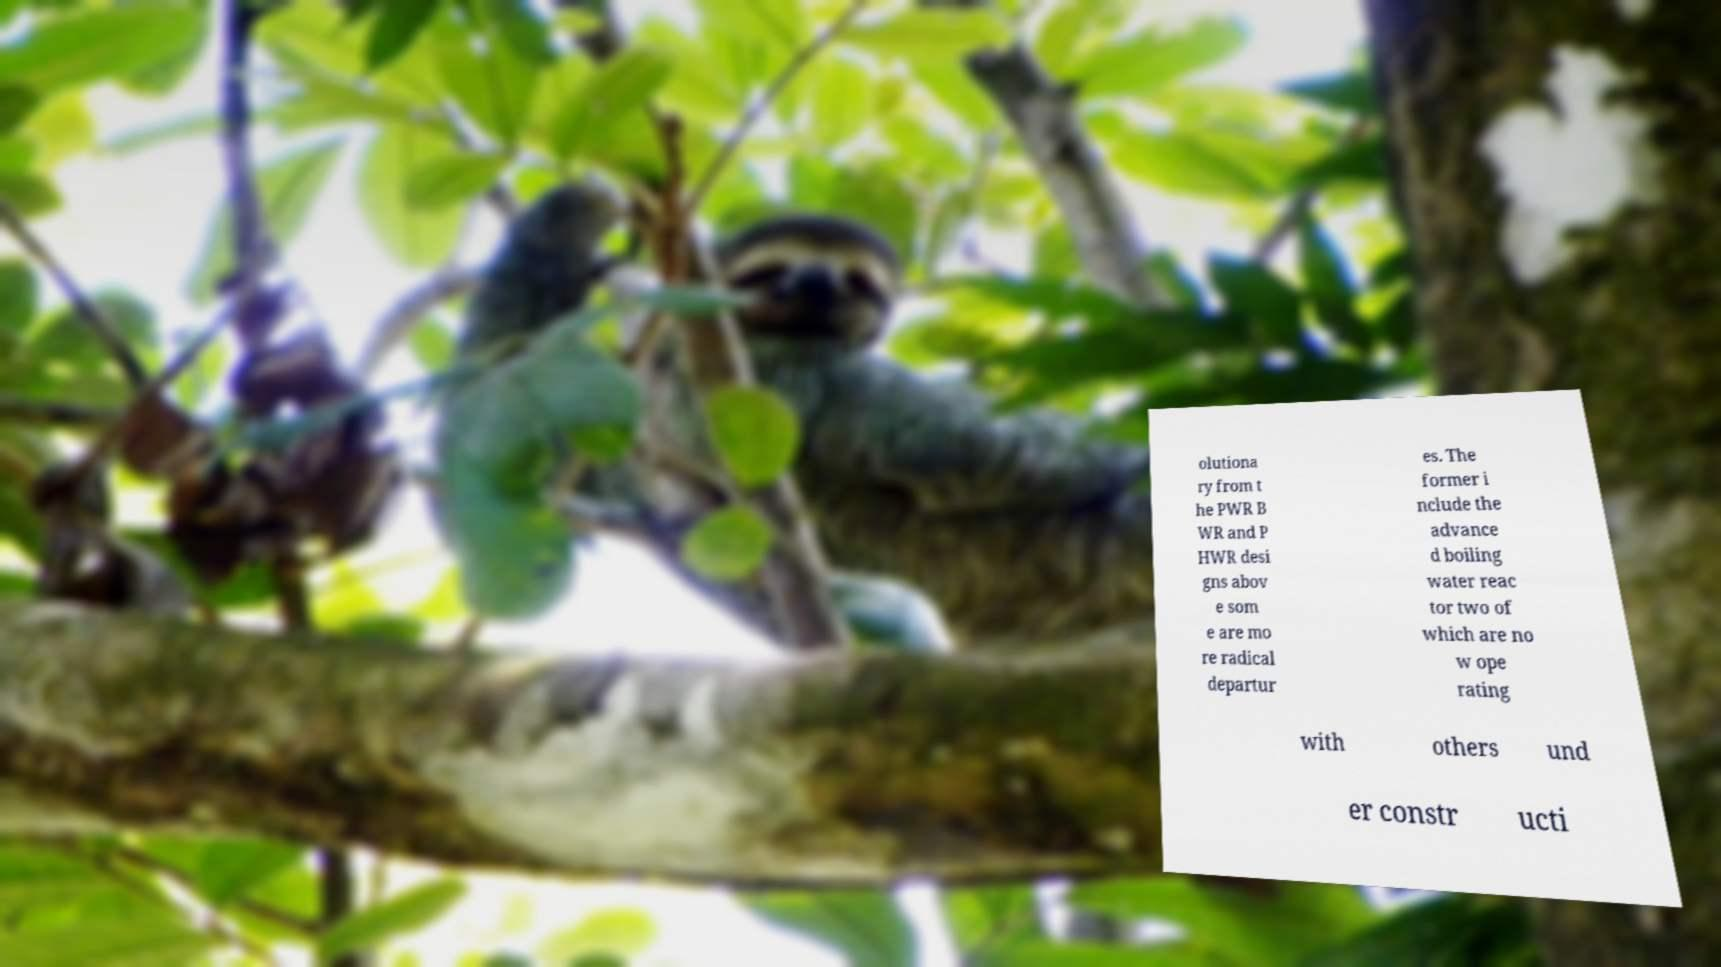Can you read and provide the text displayed in the image?This photo seems to have some interesting text. Can you extract and type it out for me? olutiona ry from t he PWR B WR and P HWR desi gns abov e som e are mo re radical departur es. The former i nclude the advance d boiling water reac tor two of which are no w ope rating with others und er constr ucti 